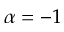<formula> <loc_0><loc_0><loc_500><loc_500>\alpha = - 1</formula> 